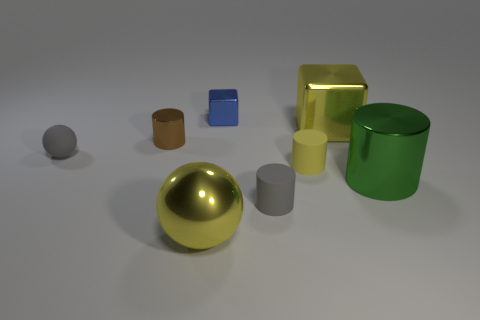There is a big green metal object; does it have the same shape as the small metal object to the left of the small blue shiny block? Yes, the big green metal object and the small metal object to the left of the small blue shiny block both have a cylindrical shape. They share the same geometric form but differ in size and possibly in material finish and hue. 